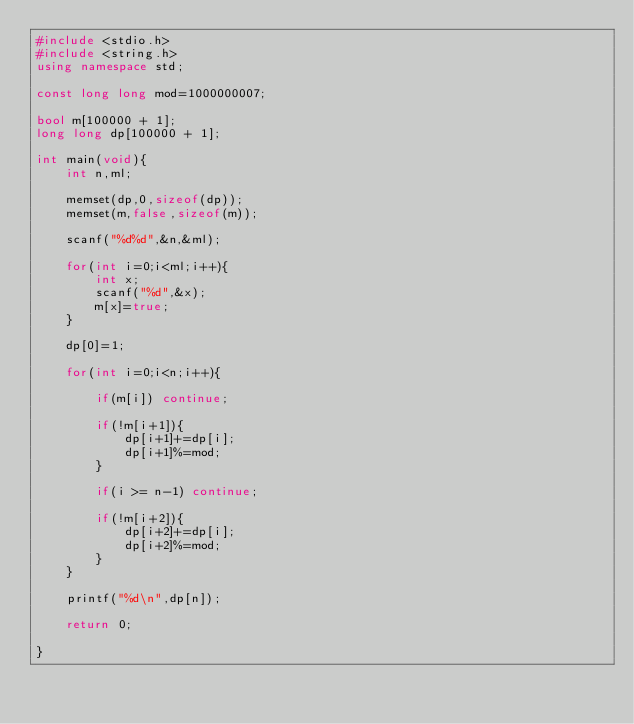<code> <loc_0><loc_0><loc_500><loc_500><_C++_>#include <stdio.h>
#include <string.h>
using namespace std;

const long long mod=1000000007;

bool m[100000 + 1];
long long dp[100000 + 1];

int main(void){
    int n,ml;
    
    memset(dp,0,sizeof(dp));
    memset(m,false,sizeof(m));
    
    scanf("%d%d",&n,&ml);
    
    for(int i=0;i<ml;i++){
        int x;
        scanf("%d",&x);
        m[x]=true;
    }
    
    dp[0]=1;
    
    for(int i=0;i<n;i++){
        
        if(m[i]) continue;
        
        if(!m[i+1]){
            dp[i+1]+=dp[i];
            dp[i+1]%=mod;
        }
       
        if(i >= n-1) continue;
       
        if(!m[i+2]){
            dp[i+2]+=dp[i];
            dp[i+2]%=mod;
        }
    }
    
    printf("%d\n",dp[n]);
    
    return 0;
    
}
</code> 